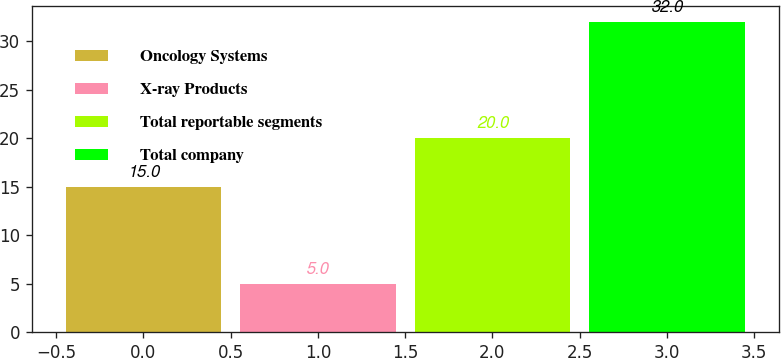<chart> <loc_0><loc_0><loc_500><loc_500><bar_chart><fcel>Oncology Systems<fcel>X-ray Products<fcel>Total reportable segments<fcel>Total company<nl><fcel>15<fcel>5<fcel>20<fcel>32<nl></chart> 